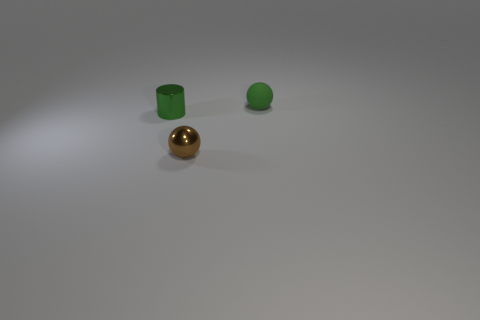There is a ball that is made of the same material as the small green cylinder; what size is it?
Your response must be concise. Small. Is the tiny green ball made of the same material as the brown ball?
Offer a very short reply. No. The tiny metallic object behind the metallic thing that is in front of the green object in front of the small green matte ball is what color?
Ensure brevity in your answer.  Green. There is a brown metallic thing; what shape is it?
Make the answer very short. Sphere. There is a small matte object; is it the same color as the metal thing that is on the left side of the brown object?
Your answer should be compact. Yes. Are there an equal number of small objects that are right of the brown metallic ball and small rubber balls?
Provide a short and direct response. Yes. What number of brown shiny things are the same size as the green cylinder?
Your answer should be very brief. 1. There is a rubber thing that is the same color as the small cylinder; what is its shape?
Your answer should be very brief. Sphere. Are any green rubber spheres visible?
Give a very brief answer. Yes. There is a green object that is in front of the small green matte thing; is its shape the same as the tiny green object that is right of the small shiny sphere?
Keep it short and to the point. No. 